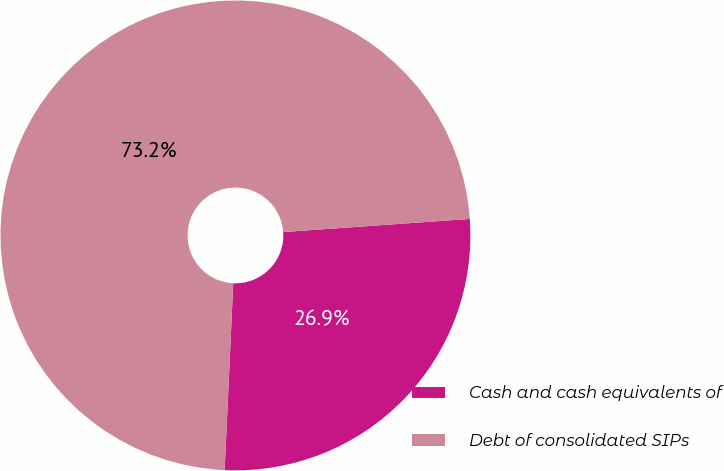Convert chart to OTSL. <chart><loc_0><loc_0><loc_500><loc_500><pie_chart><fcel>Cash and cash equivalents of<fcel>Debt of consolidated SIPs<nl><fcel>26.85%<fcel>73.15%<nl></chart> 